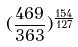Convert formula to latex. <formula><loc_0><loc_0><loc_500><loc_500>( \frac { 4 6 9 } { 3 6 3 } ) ^ { \frac { 1 5 4 } { 1 2 7 } }</formula> 